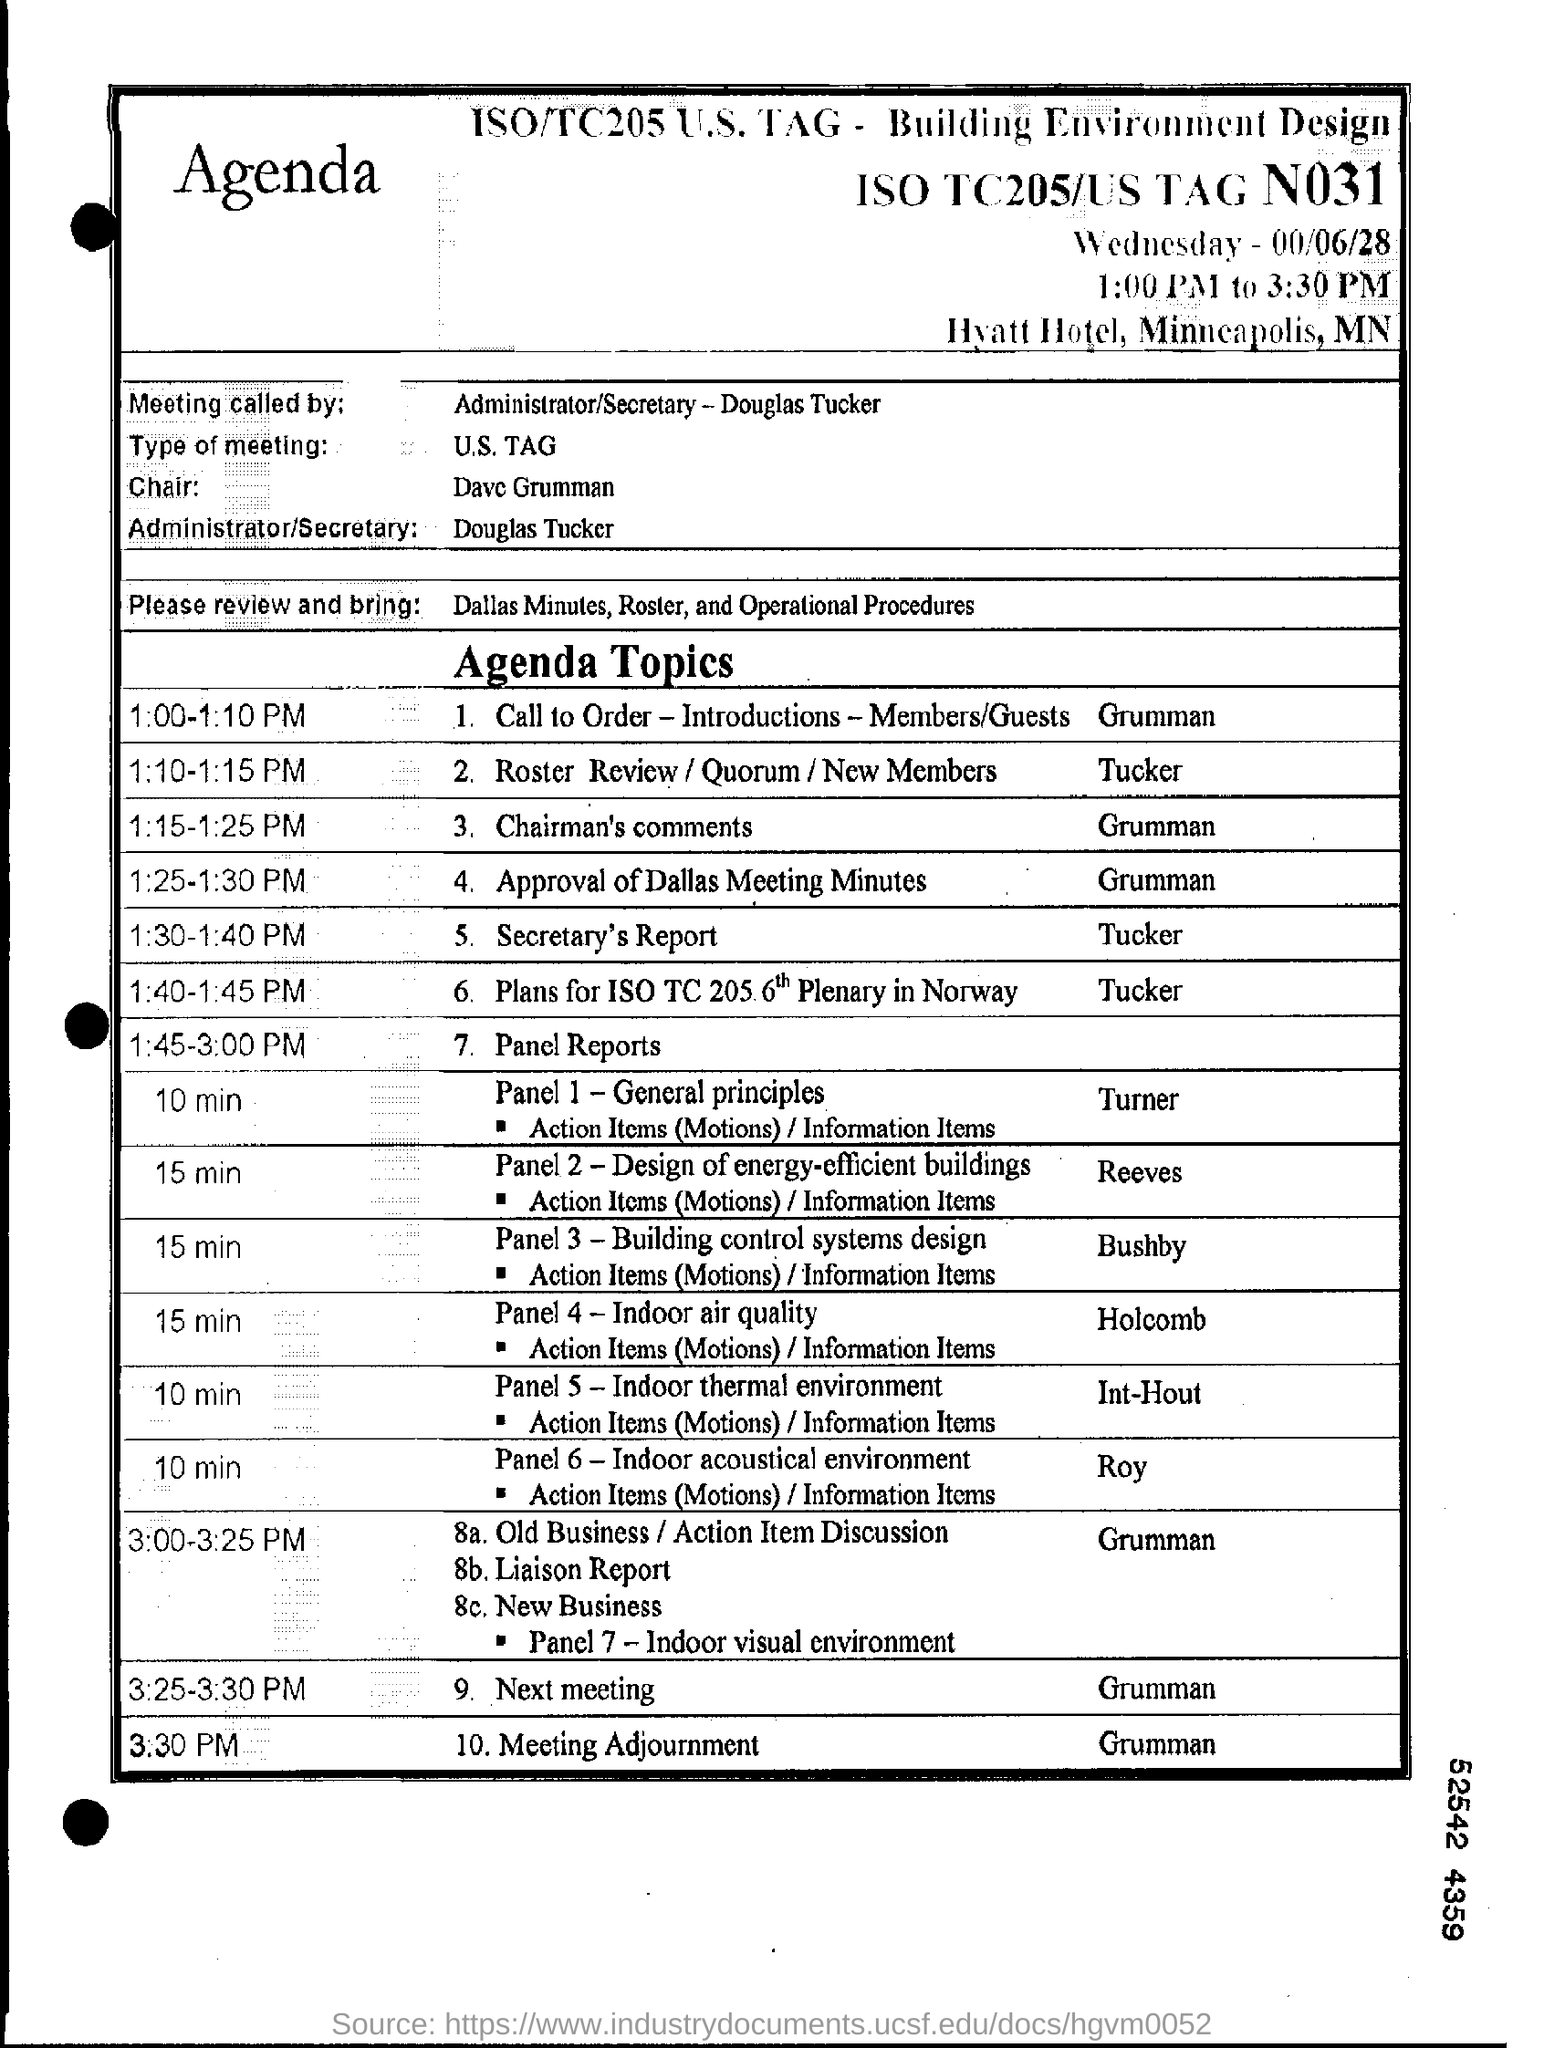Identify some key points in this picture. The name of the administrator/secretary mentioned is Douglas Tucker. The chair referred to as 'Dave Grumman' 